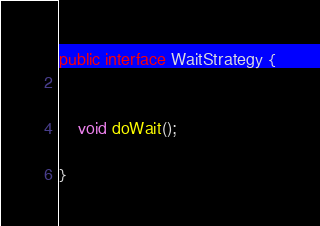<code> <loc_0><loc_0><loc_500><loc_500><_Java_>
public interface WaitStrategy {


    void doWait();

}
</code> 